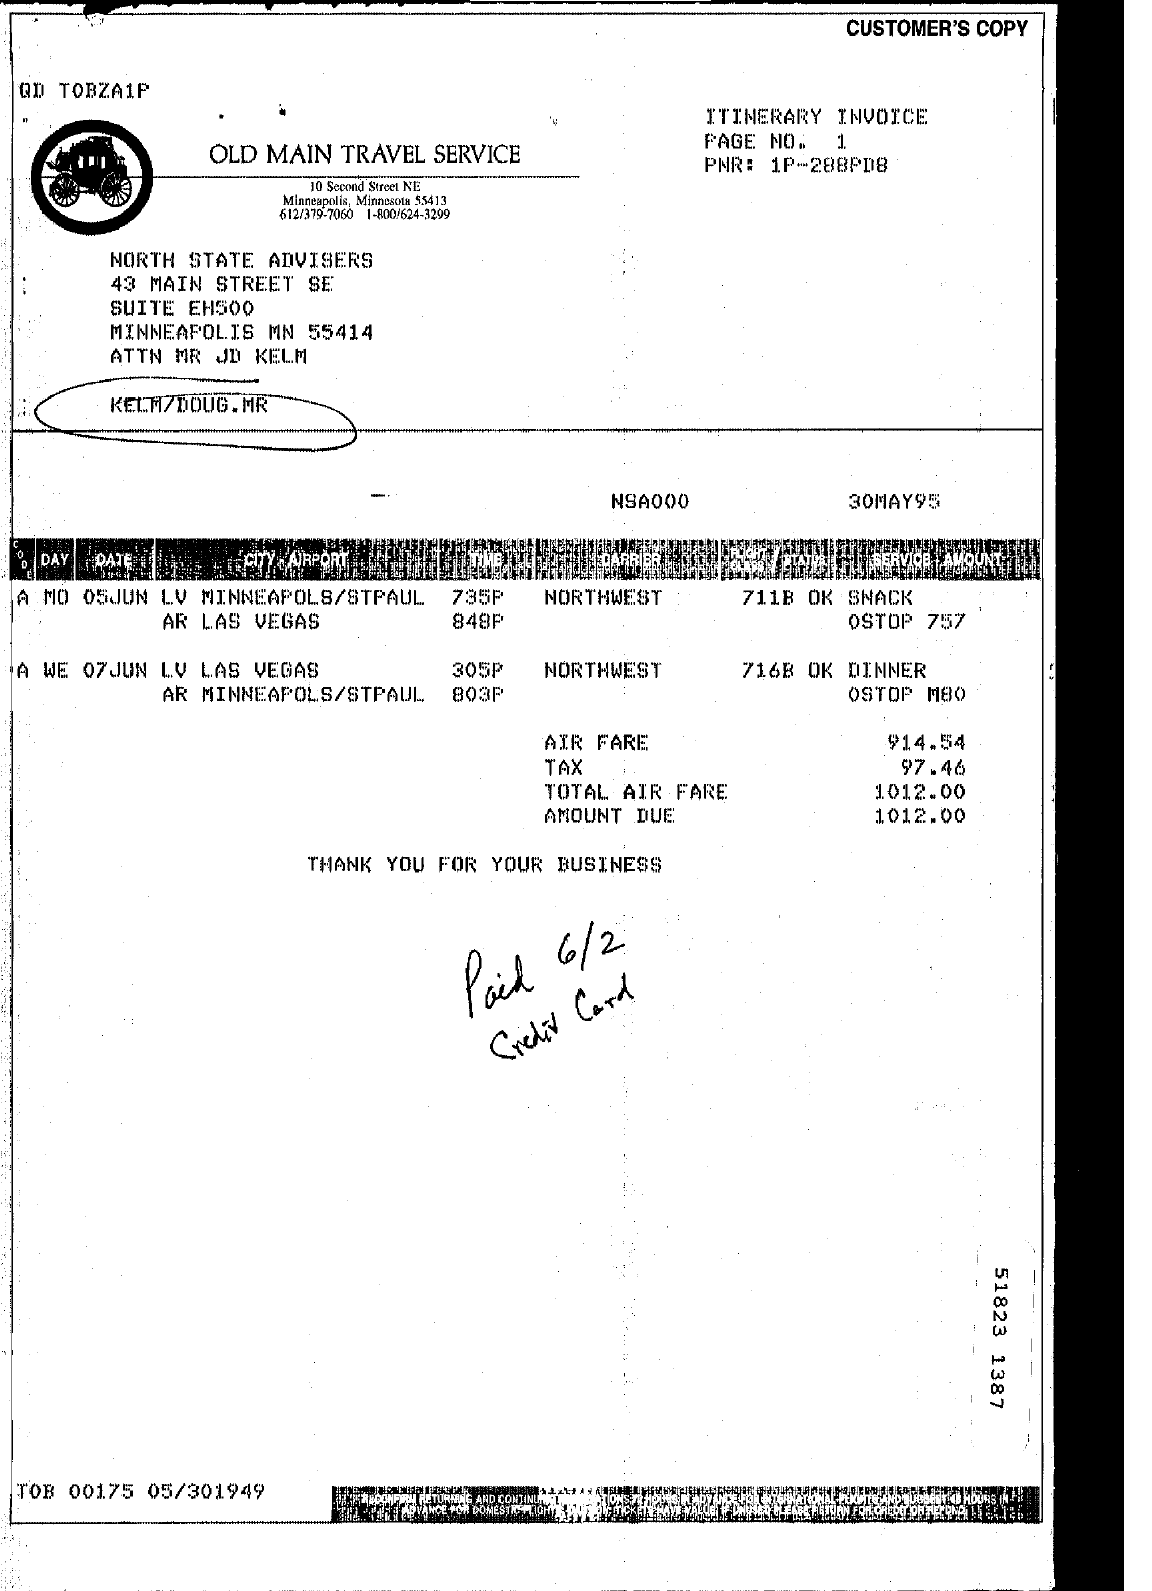What is amount due?
Offer a terse response. 1012. 